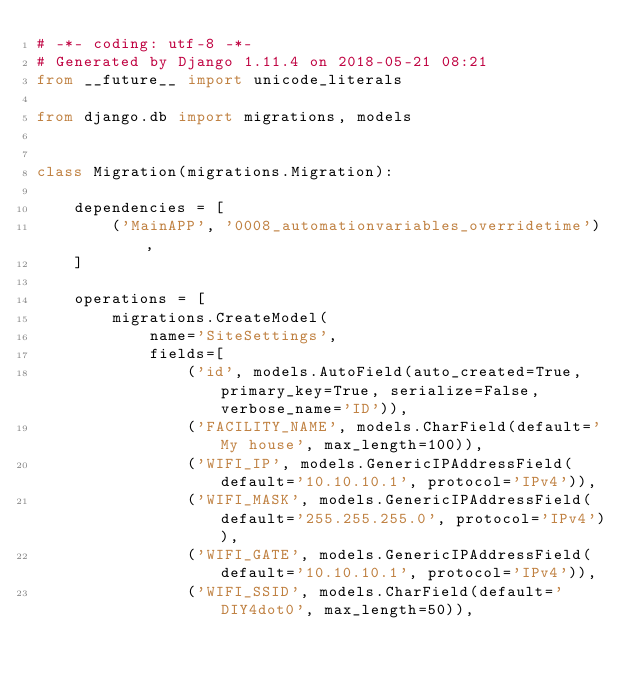Convert code to text. <code><loc_0><loc_0><loc_500><loc_500><_Python_># -*- coding: utf-8 -*-
# Generated by Django 1.11.4 on 2018-05-21 08:21
from __future__ import unicode_literals

from django.db import migrations, models


class Migration(migrations.Migration):

    dependencies = [
        ('MainAPP', '0008_automationvariables_overridetime'),
    ]

    operations = [
        migrations.CreateModel(
            name='SiteSettings',
            fields=[
                ('id', models.AutoField(auto_created=True, primary_key=True, serialize=False, verbose_name='ID')),
                ('FACILITY_NAME', models.CharField(default='My house', max_length=100)),
                ('WIFI_IP', models.GenericIPAddressField(default='10.10.10.1', protocol='IPv4')),
                ('WIFI_MASK', models.GenericIPAddressField(default='255.255.255.0', protocol='IPv4')),
                ('WIFI_GATE', models.GenericIPAddressField(default='10.10.10.1', protocol='IPv4')),
                ('WIFI_SSID', models.CharField(default='DIY4dot0', max_length=50)),</code> 